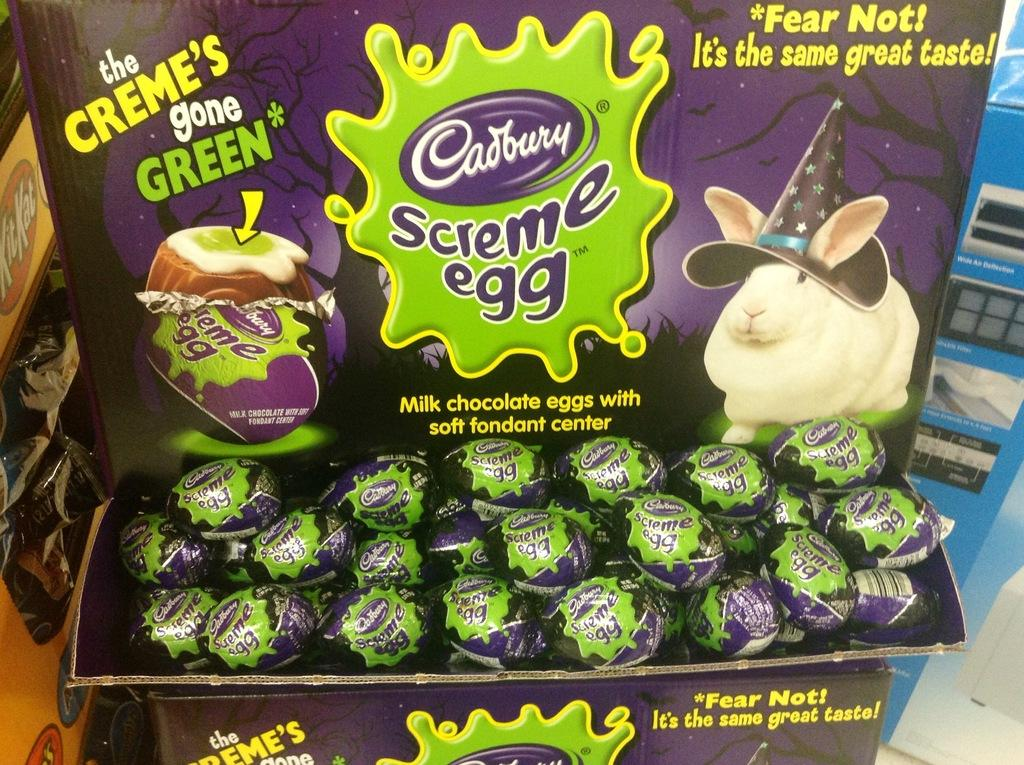What type of food is visible in the image? There is a bunch of chocolates in the image. How are the chocolates arranged or contained in the image? The chocolates are placed in a box. What type of ear can be seen attached to the chocolates in the image? There are no ears present or attached to the chocolates in the image. What type of board or skate is visible in the image? There is no board or skate present in the image. 